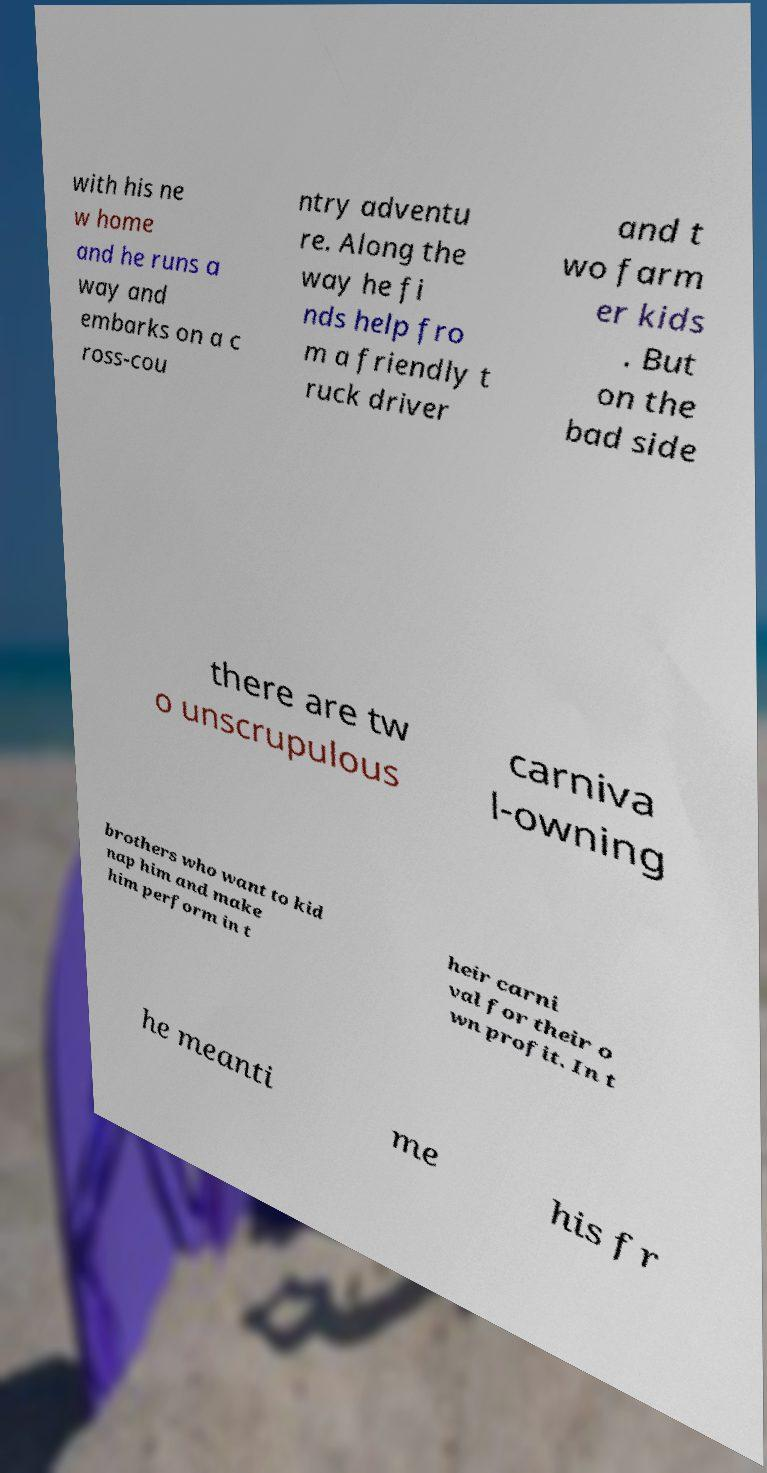What messages or text are displayed in this image? I need them in a readable, typed format. with his ne w home and he runs a way and embarks on a c ross-cou ntry adventu re. Along the way he fi nds help fro m a friendly t ruck driver and t wo farm er kids . But on the bad side there are tw o unscrupulous carniva l-owning brothers who want to kid nap him and make him perform in t heir carni val for their o wn profit. In t he meanti me his fr 